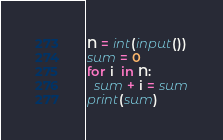Convert code to text. <code><loc_0><loc_0><loc_500><loc_500><_Python_>N = int(input())
sum = 0
for i  in N:
  sum + i = sum
print(sum)</code> 